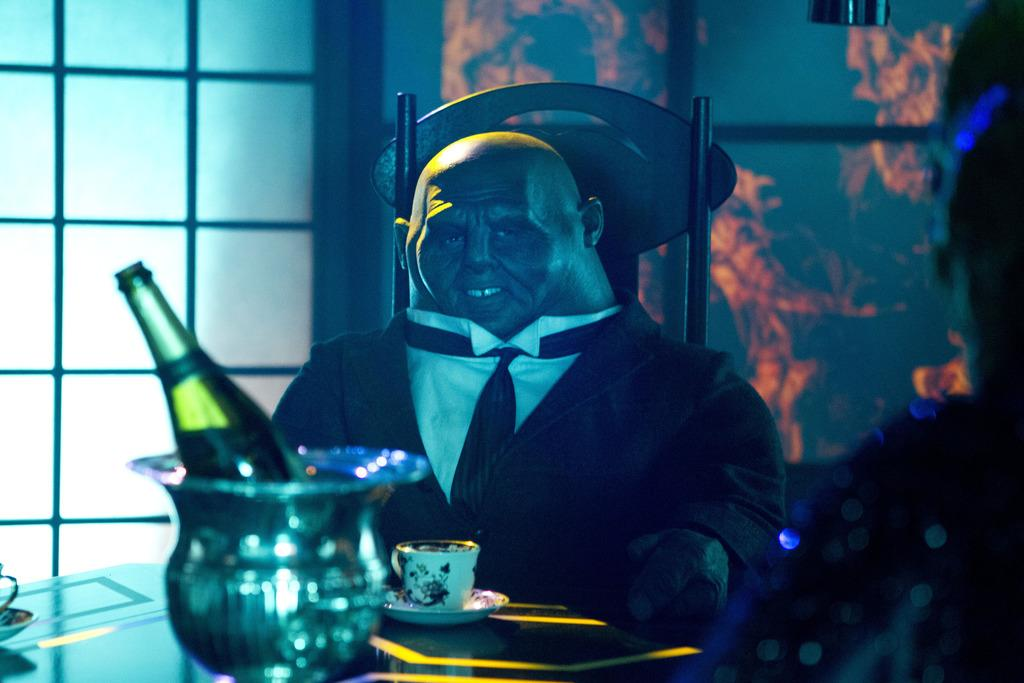What is the person in the image doing? The person is sitting on a chair in the image. What is in front of the person? The person is in front of a table. What items can be seen on the table? There is a wine bottle and a cup on the table. What can be seen in the background of the image? There is a wall and a window in the background of the image. How many sheep are visible in the image? There are no sheep present in the image. What is the person's thumb doing in the image? There is no information about the person's thumb in the image. 